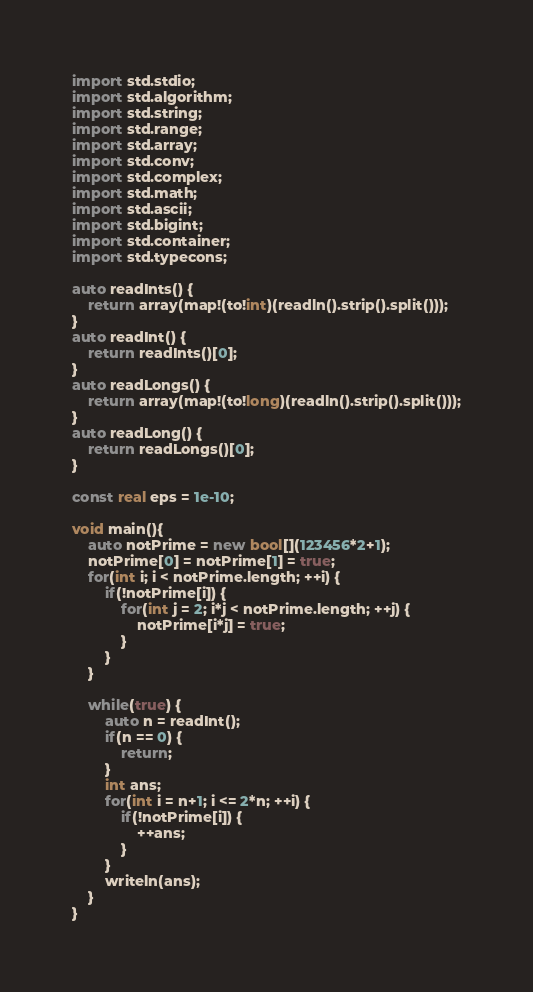Convert code to text. <code><loc_0><loc_0><loc_500><loc_500><_D_>import std.stdio;
import std.algorithm;
import std.string;
import std.range;
import std.array;
import std.conv;
import std.complex;
import std.math;
import std.ascii;
import std.bigint;
import std.container;
import std.typecons;

auto readInts() {
	return array(map!(to!int)(readln().strip().split()));
}
auto readInt() {
	return readInts()[0];
}
auto readLongs() {
	return array(map!(to!long)(readln().strip().split()));
}
auto readLong() {
	return readLongs()[0];
}

const real eps = 1e-10;

void main(){
	auto notPrime = new bool[](123456*2+1);
	notPrime[0] = notPrime[1] = true;
	for(int i; i < notPrime.length; ++i) {
		if(!notPrime[i]) {
			for(int j = 2; i*j < notPrime.length; ++j) {
				notPrime[i*j] = true;
			}
		}
	}

	while(true) {
		auto n = readInt();
		if(n == 0) {
			return;
		}
		int ans;
		for(int i = n+1; i <= 2*n; ++i) {
			if(!notPrime[i]) {
				++ans;
			}
		}
		writeln(ans);
	}
}</code> 